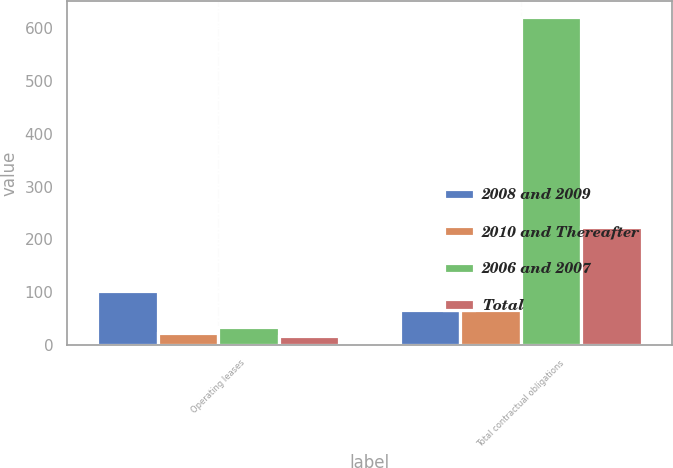Convert chart to OTSL. <chart><loc_0><loc_0><loc_500><loc_500><stacked_bar_chart><ecel><fcel>Operating leases<fcel>Total contractual obligations<nl><fcel>2008 and 2009<fcel>103<fcel>66.5<nl><fcel>2010 and Thereafter<fcel>23.5<fcel>66.5<nl><fcel>2006 and 2007<fcel>34.2<fcel>619.5<nl><fcel>Total<fcel>17.7<fcel>223.2<nl></chart> 